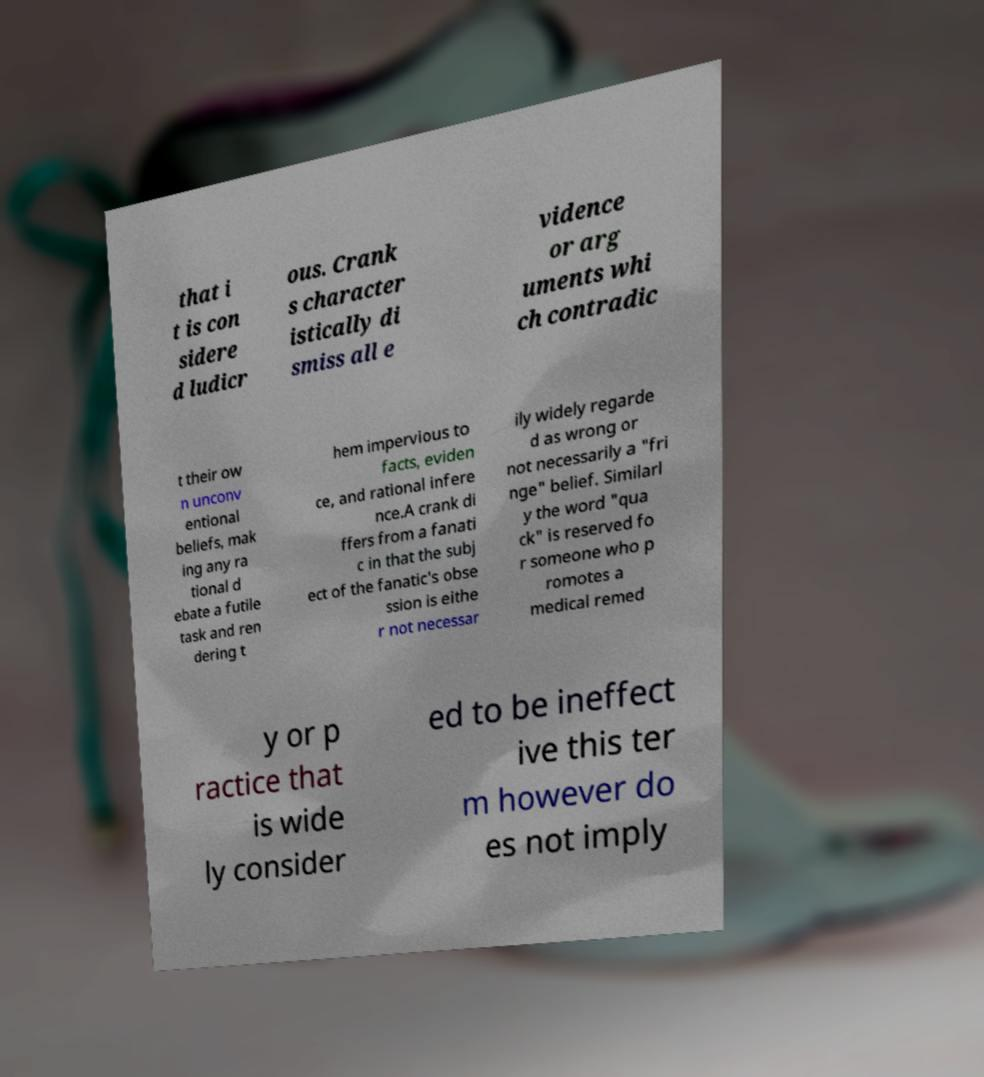What messages or text are displayed in this image? I need them in a readable, typed format. that i t is con sidere d ludicr ous. Crank s character istically di smiss all e vidence or arg uments whi ch contradic t their ow n unconv entional beliefs, mak ing any ra tional d ebate a futile task and ren dering t hem impervious to facts, eviden ce, and rational infere nce.A crank di ffers from a fanati c in that the subj ect of the fanatic's obse ssion is eithe r not necessar ily widely regarde d as wrong or not necessarily a "fri nge" belief. Similarl y the word "qua ck" is reserved fo r someone who p romotes a medical remed y or p ractice that is wide ly consider ed to be ineffect ive this ter m however do es not imply 